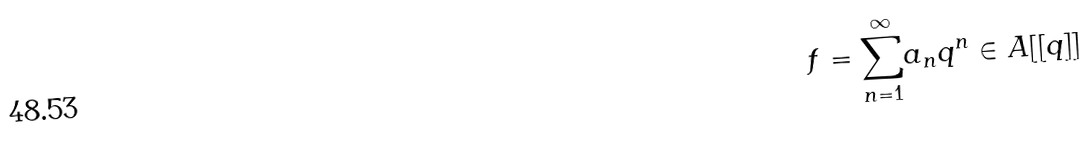<formula> <loc_0><loc_0><loc_500><loc_500>f = \underset { n = 1 } { \overset { \infty } \sum } a _ { n } q ^ { n } \in A [ [ q ] ]</formula> 